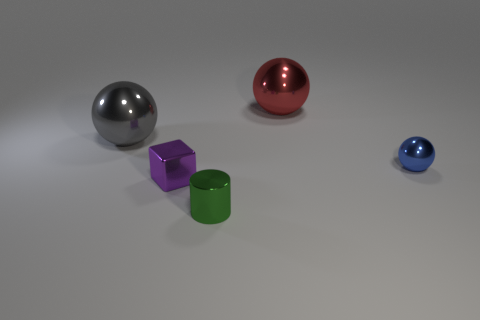Add 2 tiny gray objects. How many objects exist? 7 Subtract all yellow cylinders. Subtract all large gray balls. How many objects are left? 4 Add 3 big red shiny spheres. How many big red shiny spheres are left? 4 Add 1 tiny things. How many tiny things exist? 4 Subtract 1 red balls. How many objects are left? 4 Subtract all balls. How many objects are left? 2 